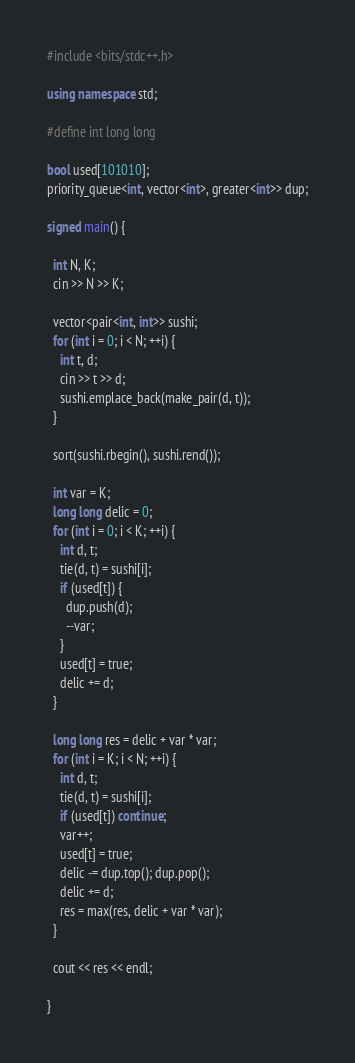<code> <loc_0><loc_0><loc_500><loc_500><_C++_>#include <bits/stdc++.h>

using namespace std;

#define int long long

bool used[101010];
priority_queue<int, vector<int>, greater<int>> dup;

signed main() {

  int N, K;
  cin >> N >> K;

  vector<pair<int, int>> sushi;
  for (int i = 0; i < N; ++i) {
    int t, d;
    cin >> t >> d;
    sushi.emplace_back(make_pair(d, t));
  }

  sort(sushi.rbegin(), sushi.rend());

  int var = K;
  long long delic = 0;
  for (int i = 0; i < K; ++i) {
    int d, t;
    tie(d, t) = sushi[i];
    if (used[t]) {
      dup.push(d);
      --var;
    }
    used[t] = true;
    delic += d;
  }

  long long res = delic + var * var;
  for (int i = K; i < N; ++i) {
    int d, t;
    tie(d, t) = sushi[i];
    if (used[t]) continue;
    var++;
    used[t] = true;
    delic -= dup.top(); dup.pop();
    delic += d;
    res = max(res, delic + var * var);
  }

  cout << res << endl;

}
</code> 